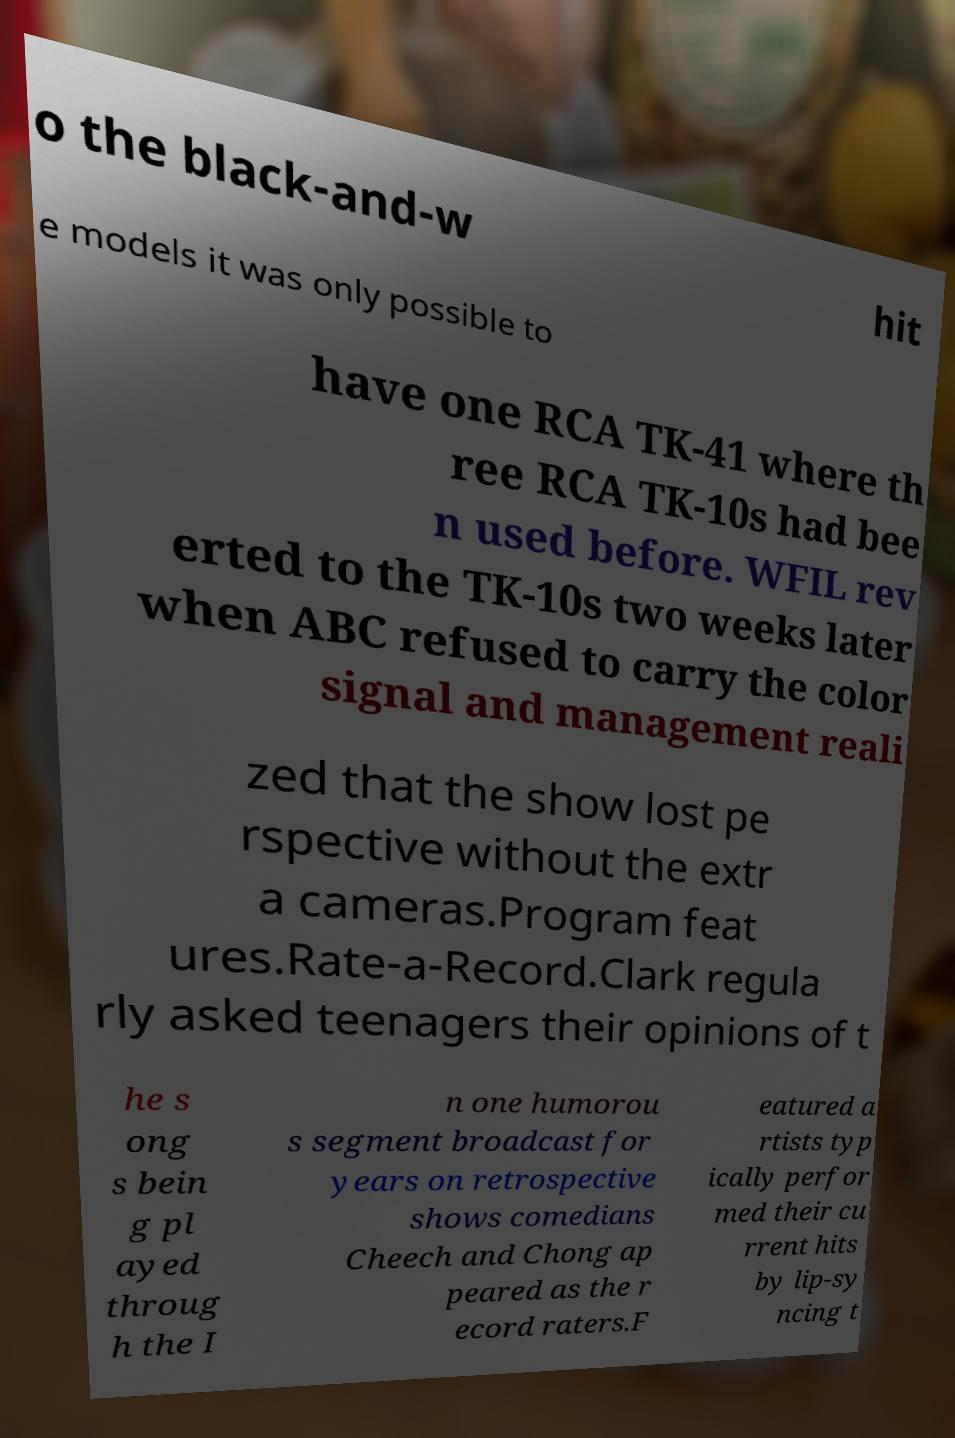Please identify and transcribe the text found in this image. o the black-and-w hit e models it was only possible to have one RCA TK-41 where th ree RCA TK-10s had bee n used before. WFIL rev erted to the TK-10s two weeks later when ABC refused to carry the color signal and management reali zed that the show lost pe rspective without the extr a cameras.Program feat ures.Rate-a-Record.Clark regula rly asked teenagers their opinions of t he s ong s bein g pl ayed throug h the I n one humorou s segment broadcast for years on retrospective shows comedians Cheech and Chong ap peared as the r ecord raters.F eatured a rtists typ ically perfor med their cu rrent hits by lip-sy ncing t 